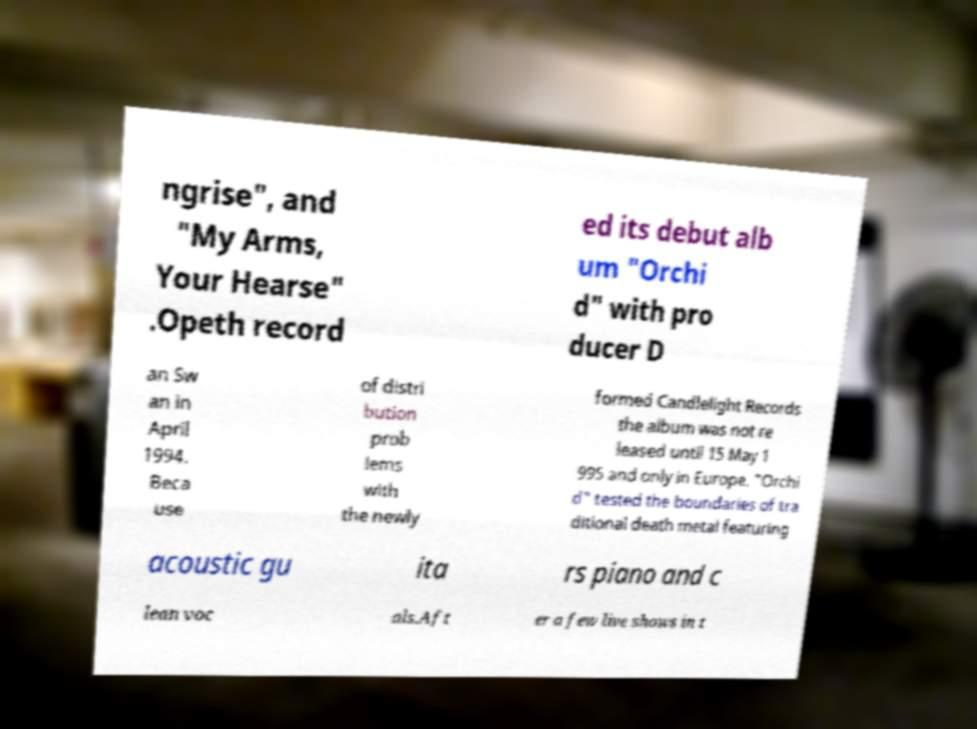What messages or text are displayed in this image? I need them in a readable, typed format. ngrise", and "My Arms, Your Hearse" .Opeth record ed its debut alb um "Orchi d" with pro ducer D an Sw an in April 1994. Beca use of distri bution prob lems with the newly formed Candlelight Records the album was not re leased until 15 May 1 995 and only in Europe. "Orchi d" tested the boundaries of tra ditional death metal featuring acoustic gu ita rs piano and c lean voc als.Aft er a few live shows in t 